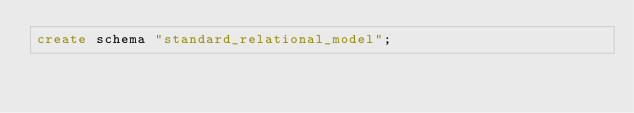<code> <loc_0><loc_0><loc_500><loc_500><_SQL_>create schema "standard_relational_model";
</code> 